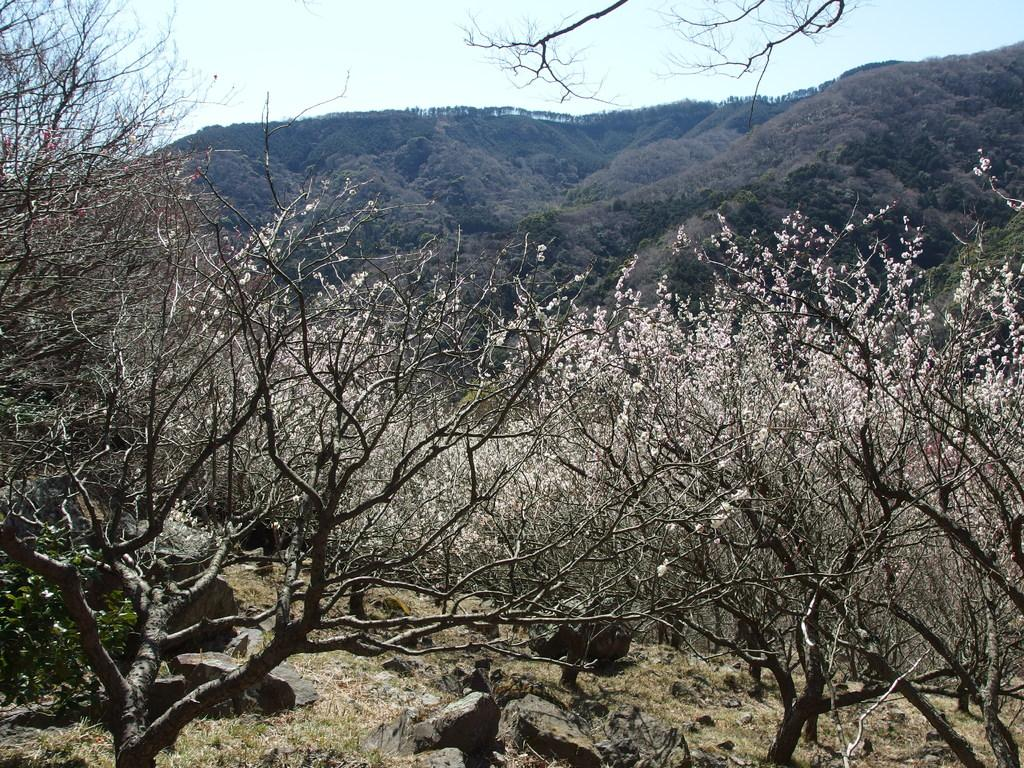What type of vegetation is present in the image? There are trees in the image. What natural feature can be seen in the distance? There are mountains in the background of the image. What part of the natural environment is visible in the image? The sky is visible in the image. What type of flowers can be seen growing near the trees in the image? There are no flowers mentioned or visible in the image; only trees and mountains are present. 